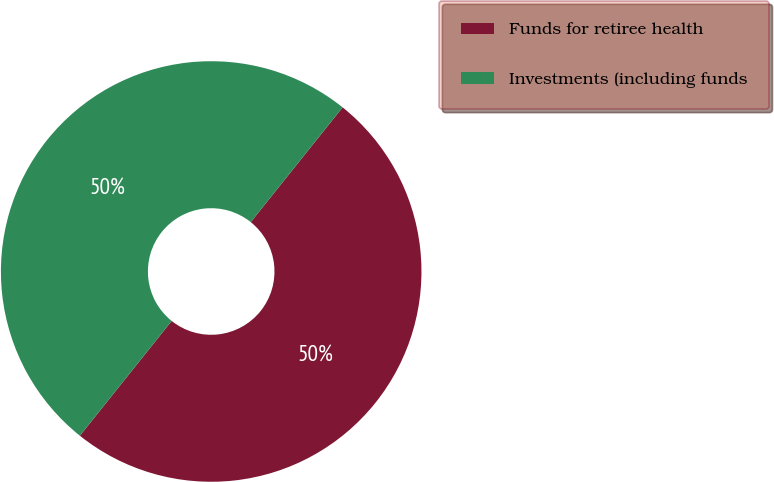Convert chart. <chart><loc_0><loc_0><loc_500><loc_500><pie_chart><fcel>Funds for retiree health<fcel>Investments (including funds<nl><fcel>49.99%<fcel>50.01%<nl></chart> 